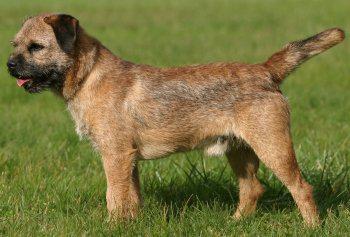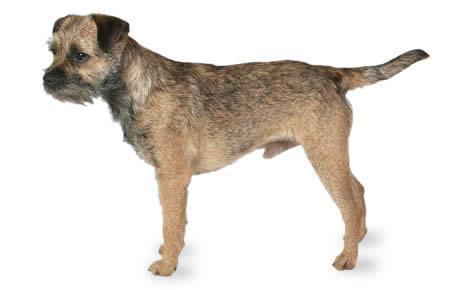The first image is the image on the left, the second image is the image on the right. Assess this claim about the two images: "Both dogs are facing the same direction.". Correct or not? Answer yes or no. Yes. The first image is the image on the left, the second image is the image on the right. Considering the images on both sides, is "One dog is wearing a collar or leash, and the other dog is not." valid? Answer yes or no. No. The first image is the image on the left, the second image is the image on the right. Considering the images on both sides, is "The right image has exactly one dog who's body is facing towards the left." valid? Answer yes or no. Yes. The first image is the image on the left, the second image is the image on the right. Examine the images to the left and right. Is the description "1 of the dogs has a tail that is in a resting position." accurate? Answer yes or no. No. 